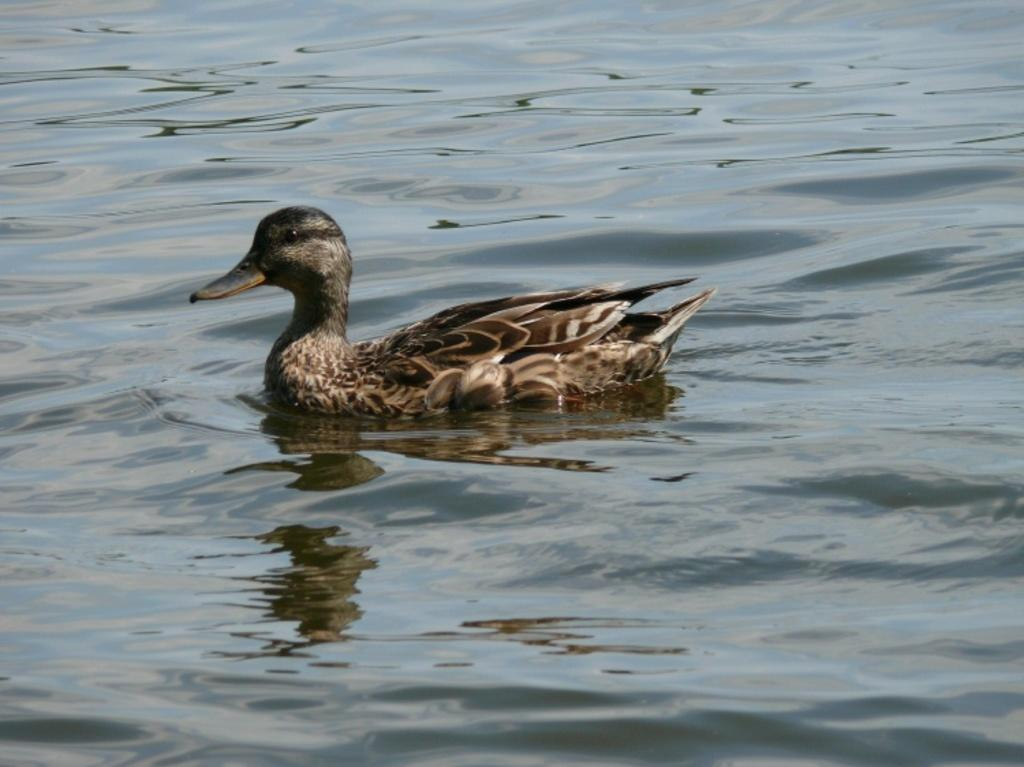What animal is present in the image? There is a duck in the image. Where is the duck located? The duck is on the water. What type of doll can be seen playing in the band with the tiger in the image? There is no doll, band, or tiger present in the image; it only features a duck on the water. 